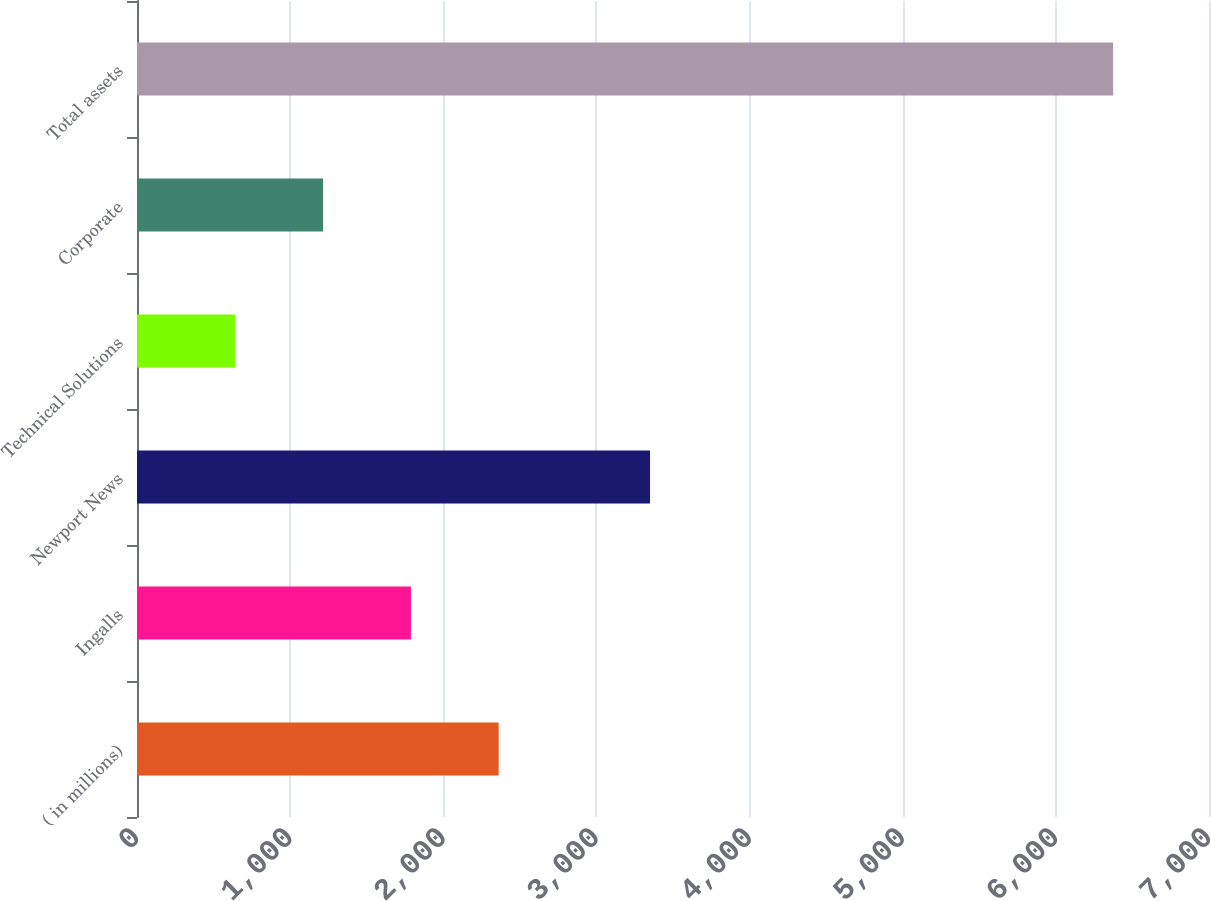Convert chart. <chart><loc_0><loc_0><loc_500><loc_500><bar_chart><fcel>( in millions)<fcel>Ingalls<fcel>Newport News<fcel>Technical Solutions<fcel>Corporate<fcel>Total assets<nl><fcel>2361.6<fcel>1788.4<fcel>3350<fcel>642<fcel>1215.2<fcel>6374<nl></chart> 